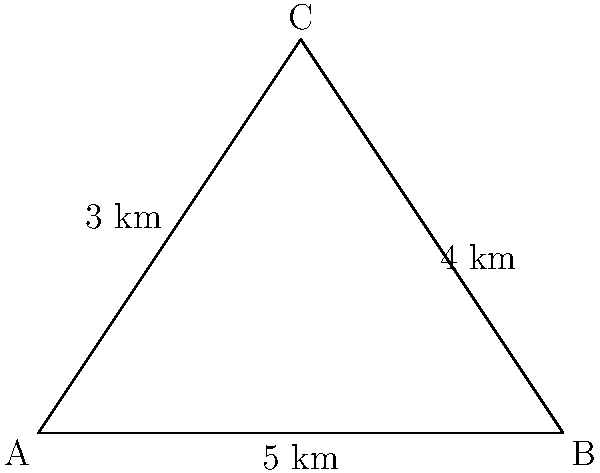A triangular green waste collection zone has been established with side lengths of 3 km, 4 km, and 5 km. What is the perimeter of this collection zone? To calculate the perimeter of the triangular green waste collection zone, we need to sum up the lengths of all three sides:

1. Side 1: 3 km
2. Side 2: 4 km
3. Side 3: 5 km

Perimeter = Side 1 + Side 2 + Side 3
           = 3 km + 4 km + 5 km
           = 12 km

Therefore, the perimeter of the triangular green waste collection zone is 12 km.
Answer: 12 km 